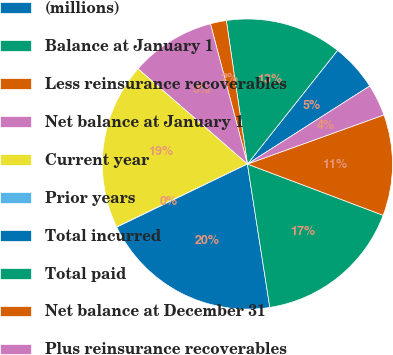<chart> <loc_0><loc_0><loc_500><loc_500><pie_chart><fcel>(millions)<fcel>Balance at January 1<fcel>Less reinsurance recoverables<fcel>Net balance at January 1<fcel>Current year<fcel>Prior years<fcel>Total incurred<fcel>Total paid<fcel>Net balance at December 31<fcel>Plus reinsurance recoverables<nl><fcel>5.29%<fcel>12.99%<fcel>1.78%<fcel>9.49%<fcel>18.54%<fcel>0.03%<fcel>20.3%<fcel>16.79%<fcel>11.24%<fcel>3.54%<nl></chart> 